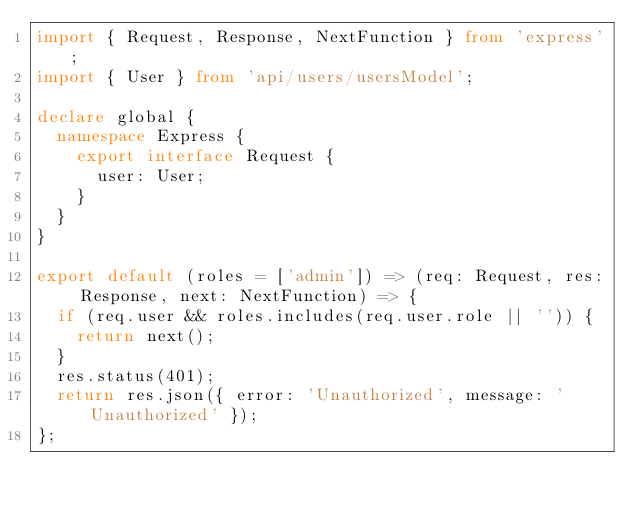Convert code to text. <code><loc_0><loc_0><loc_500><loc_500><_TypeScript_>import { Request, Response, NextFunction } from 'express';
import { User } from 'api/users/usersModel';

declare global {
  namespace Express {
    export interface Request {
      user: User;
    }
  }
}

export default (roles = ['admin']) => (req: Request, res: Response, next: NextFunction) => {
  if (req.user && roles.includes(req.user.role || '')) {
    return next();
  }
  res.status(401);
  return res.json({ error: 'Unauthorized', message: 'Unauthorized' });
};
</code> 